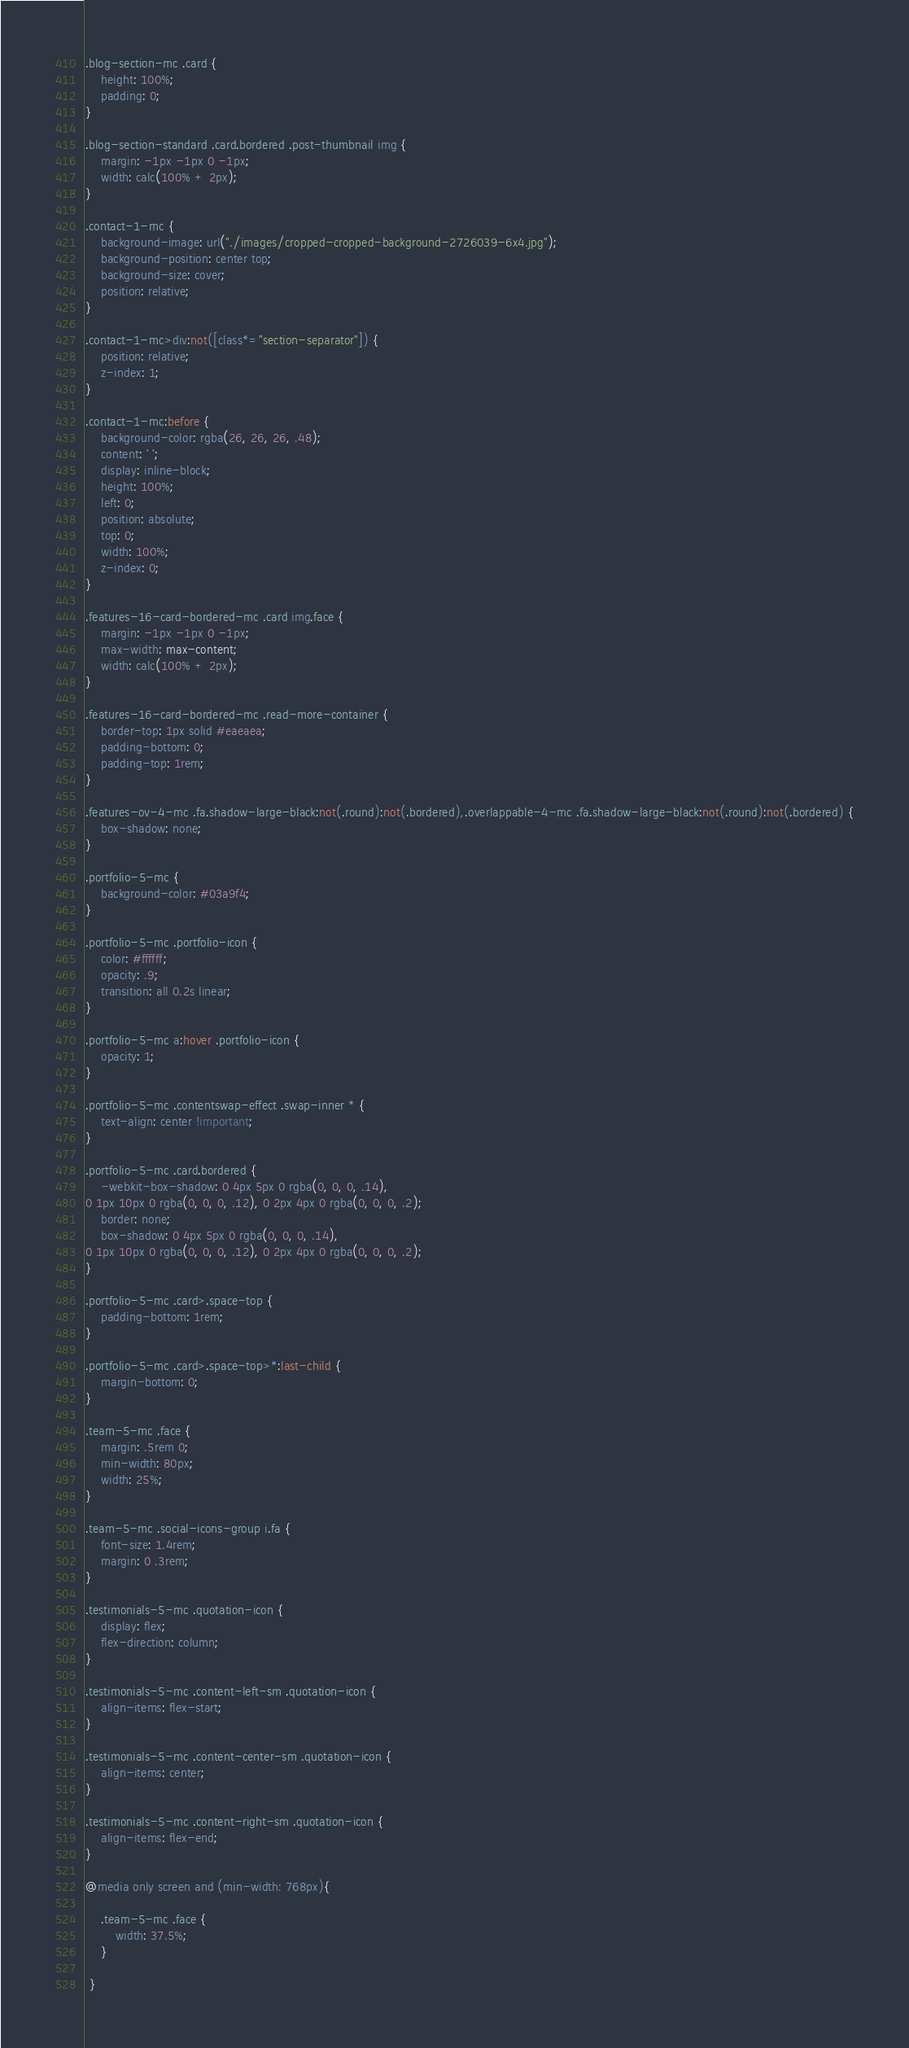<code> <loc_0><loc_0><loc_500><loc_500><_CSS_>.blog-section-mc .card {
	height: 100%;
	padding: 0;
}

.blog-section-standard .card.bordered .post-thumbnail img {
	margin: -1px -1px 0 -1px;
	width: calc(100% + 2px);
}

.contact-1-mc {
	background-image: url("./images/cropped-cropped-background-2726039-6x4.jpg");
	background-position: center top;
	background-size: cover;
	position: relative;
}

.contact-1-mc>div:not([class*="section-separator"]) {
	position: relative;
	z-index: 1;
}

.contact-1-mc:before {
	background-color: rgba(26, 26, 26, .48);
	content: ' ';
	display: inline-block;
	height: 100%;
	left: 0;
	position: absolute;
	top: 0;
	width: 100%;
	z-index: 0;
}

.features-16-card-bordered-mc .card img.face {
	margin: -1px -1px 0 -1px;
	max-width: max-content;
	width: calc(100% + 2px);
}

.features-16-card-bordered-mc .read-more-container {
	border-top: 1px solid #eaeaea;
	padding-bottom: 0;
	padding-top: 1rem;
}

.features-ov-4-mc .fa.shadow-large-black:not(.round):not(.bordered),.overlappable-4-mc .fa.shadow-large-black:not(.round):not(.bordered) {
	box-shadow: none;
}

.portfolio-5-mc {
	background-color: #03a9f4;
}

.portfolio-5-mc .portfolio-icon {
	color: #ffffff;
	opacity: .9;
	transition: all 0.2s linear;
}

.portfolio-5-mc a:hover .portfolio-icon {
	opacity: 1;
}

.portfolio-5-mc .contentswap-effect .swap-inner * {
	text-align: center !important;
}

.portfolio-5-mc .card.bordered {
	-webkit-box-shadow: 0 4px 5px 0 rgba(0, 0, 0, .14),
0 1px 10px 0 rgba(0, 0, 0, .12), 0 2px 4px 0 rgba(0, 0, 0, .2);
	border: none;
	box-shadow: 0 4px 5px 0 rgba(0, 0, 0, .14),
0 1px 10px 0 rgba(0, 0, 0, .12), 0 2px 4px 0 rgba(0, 0, 0, .2);
}

.portfolio-5-mc .card>.space-top {
	padding-bottom: 1rem;
}

.portfolio-5-mc .card>.space-top>*:last-child {
	margin-bottom: 0;
}

.team-5-mc .face {
	margin: .5rem 0;
	min-width: 80px;
	width: 25%;
}

.team-5-mc .social-icons-group i.fa {
	font-size: 1.4rem;
	margin: 0 .3rem;
}

.testimonials-5-mc .quotation-icon {
	display: flex;
	flex-direction: column;
}

.testimonials-5-mc .content-left-sm .quotation-icon {
	align-items: flex-start;
}

.testimonials-5-mc .content-center-sm .quotation-icon {
	align-items: center;
}

.testimonials-5-mc .content-right-sm .quotation-icon {
	align-items: flex-end;
}

@media only screen and (min-width: 768px){ 

	.team-5-mc .face {
		width: 37.5%;
	}
	
 }
</code> 